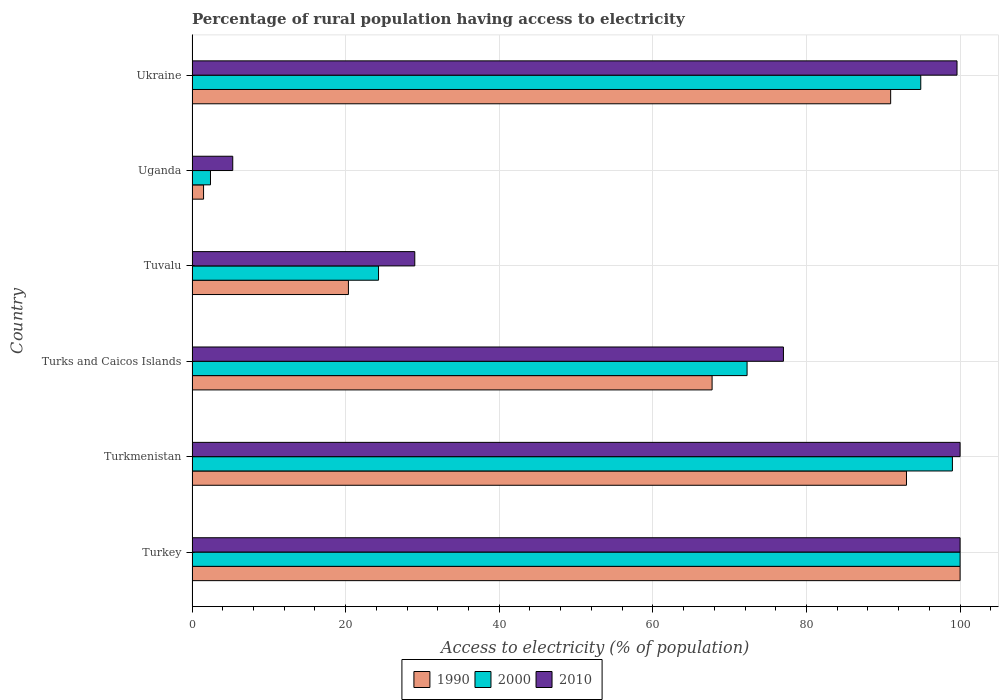How many groups of bars are there?
Ensure brevity in your answer.  6. Are the number of bars on each tick of the Y-axis equal?
Your answer should be very brief. Yes. How many bars are there on the 1st tick from the bottom?
Your answer should be very brief. 3. What is the label of the 4th group of bars from the top?
Offer a very short reply. Turks and Caicos Islands. What is the percentage of rural population having access to electricity in 1990 in Turkmenistan?
Give a very brief answer. 93.02. Across all countries, what is the maximum percentage of rural population having access to electricity in 2010?
Your response must be concise. 100. In which country was the percentage of rural population having access to electricity in 1990 minimum?
Offer a very short reply. Uganda. What is the total percentage of rural population having access to electricity in 2000 in the graph?
Provide a succinct answer. 392.83. What is the difference between the percentage of rural population having access to electricity in 2010 in Uganda and that in Ukraine?
Make the answer very short. -94.3. What is the difference between the percentage of rural population having access to electricity in 2000 in Uganda and the percentage of rural population having access to electricity in 1990 in Tuvalu?
Provide a short and direct response. -17.96. What is the average percentage of rural population having access to electricity in 2010 per country?
Your answer should be very brief. 68.48. What is the difference between the percentage of rural population having access to electricity in 2010 and percentage of rural population having access to electricity in 1990 in Turkmenistan?
Ensure brevity in your answer.  6.98. In how many countries, is the percentage of rural population having access to electricity in 2000 greater than 84 %?
Provide a short and direct response. 3. What is the ratio of the percentage of rural population having access to electricity in 1990 in Uganda to that in Ukraine?
Ensure brevity in your answer.  0.02. What is the difference between the highest and the second highest percentage of rural population having access to electricity in 2010?
Provide a short and direct response. 0. What is the difference between the highest and the lowest percentage of rural population having access to electricity in 2000?
Your response must be concise. 97.6. What does the 2nd bar from the top in Turks and Caicos Islands represents?
Provide a succinct answer. 2000. How many bars are there?
Give a very brief answer. 18. How many countries are there in the graph?
Your answer should be compact. 6. What is the difference between two consecutive major ticks on the X-axis?
Provide a succinct answer. 20. Are the values on the major ticks of X-axis written in scientific E-notation?
Offer a terse response. No. Where does the legend appear in the graph?
Ensure brevity in your answer.  Bottom center. How many legend labels are there?
Your response must be concise. 3. What is the title of the graph?
Keep it short and to the point. Percentage of rural population having access to electricity. What is the label or title of the X-axis?
Your response must be concise. Access to electricity (% of population). What is the label or title of the Y-axis?
Your answer should be very brief. Country. What is the Access to electricity (% of population) of 1990 in Turkey?
Give a very brief answer. 100. What is the Access to electricity (% of population) of 1990 in Turkmenistan?
Your answer should be compact. 93.02. What is the Access to electricity (% of population) of 2000 in Turkmenistan?
Keep it short and to the point. 99. What is the Access to electricity (% of population) of 1990 in Turks and Caicos Islands?
Your response must be concise. 67.71. What is the Access to electricity (% of population) of 2000 in Turks and Caicos Islands?
Provide a short and direct response. 72.27. What is the Access to electricity (% of population) in 2010 in Turks and Caicos Islands?
Your answer should be very brief. 77. What is the Access to electricity (% of population) of 1990 in Tuvalu?
Provide a short and direct response. 20.36. What is the Access to electricity (% of population) of 2000 in Tuvalu?
Offer a very short reply. 24.28. What is the Access to electricity (% of population) of 2000 in Uganda?
Give a very brief answer. 2.4. What is the Access to electricity (% of population) in 1990 in Ukraine?
Give a very brief answer. 90.96. What is the Access to electricity (% of population) in 2000 in Ukraine?
Provide a short and direct response. 94.88. What is the Access to electricity (% of population) in 2010 in Ukraine?
Provide a succinct answer. 99.6. Across all countries, what is the maximum Access to electricity (% of population) in 1990?
Offer a terse response. 100. Across all countries, what is the minimum Access to electricity (% of population) of 1990?
Provide a short and direct response. 1.5. Across all countries, what is the minimum Access to electricity (% of population) of 2010?
Provide a short and direct response. 5.3. What is the total Access to electricity (% of population) of 1990 in the graph?
Provide a short and direct response. 373.55. What is the total Access to electricity (% of population) in 2000 in the graph?
Offer a very short reply. 392.83. What is the total Access to electricity (% of population) in 2010 in the graph?
Give a very brief answer. 410.9. What is the difference between the Access to electricity (% of population) of 1990 in Turkey and that in Turkmenistan?
Your answer should be very brief. 6.98. What is the difference between the Access to electricity (% of population) of 2000 in Turkey and that in Turkmenistan?
Your response must be concise. 1. What is the difference between the Access to electricity (% of population) in 2010 in Turkey and that in Turkmenistan?
Provide a succinct answer. 0. What is the difference between the Access to electricity (% of population) of 1990 in Turkey and that in Turks and Caicos Islands?
Keep it short and to the point. 32.29. What is the difference between the Access to electricity (% of population) of 2000 in Turkey and that in Turks and Caicos Islands?
Keep it short and to the point. 27.73. What is the difference between the Access to electricity (% of population) of 1990 in Turkey and that in Tuvalu?
Offer a very short reply. 79.64. What is the difference between the Access to electricity (% of population) in 2000 in Turkey and that in Tuvalu?
Your answer should be very brief. 75.72. What is the difference between the Access to electricity (% of population) of 1990 in Turkey and that in Uganda?
Provide a short and direct response. 98.5. What is the difference between the Access to electricity (% of population) of 2000 in Turkey and that in Uganda?
Your answer should be very brief. 97.6. What is the difference between the Access to electricity (% of population) of 2010 in Turkey and that in Uganda?
Provide a succinct answer. 94.7. What is the difference between the Access to electricity (% of population) of 1990 in Turkey and that in Ukraine?
Ensure brevity in your answer.  9.04. What is the difference between the Access to electricity (% of population) in 2000 in Turkey and that in Ukraine?
Make the answer very short. 5.12. What is the difference between the Access to electricity (% of population) in 2010 in Turkey and that in Ukraine?
Ensure brevity in your answer.  0.4. What is the difference between the Access to electricity (% of population) of 1990 in Turkmenistan and that in Turks and Caicos Islands?
Provide a short and direct response. 25.31. What is the difference between the Access to electricity (% of population) in 2000 in Turkmenistan and that in Turks and Caicos Islands?
Provide a short and direct response. 26.73. What is the difference between the Access to electricity (% of population) in 2010 in Turkmenistan and that in Turks and Caicos Islands?
Your response must be concise. 23. What is the difference between the Access to electricity (% of population) in 1990 in Turkmenistan and that in Tuvalu?
Give a very brief answer. 72.66. What is the difference between the Access to electricity (% of population) in 2000 in Turkmenistan and that in Tuvalu?
Your answer should be very brief. 74.72. What is the difference between the Access to electricity (% of population) in 1990 in Turkmenistan and that in Uganda?
Give a very brief answer. 91.52. What is the difference between the Access to electricity (% of population) of 2000 in Turkmenistan and that in Uganda?
Offer a very short reply. 96.6. What is the difference between the Access to electricity (% of population) of 2010 in Turkmenistan and that in Uganda?
Provide a succinct answer. 94.7. What is the difference between the Access to electricity (% of population) of 1990 in Turkmenistan and that in Ukraine?
Keep it short and to the point. 2.06. What is the difference between the Access to electricity (% of population) of 2000 in Turkmenistan and that in Ukraine?
Your answer should be compact. 4.12. What is the difference between the Access to electricity (% of population) in 2010 in Turkmenistan and that in Ukraine?
Keep it short and to the point. 0.4. What is the difference between the Access to electricity (% of population) in 1990 in Turks and Caicos Islands and that in Tuvalu?
Your answer should be compact. 47.35. What is the difference between the Access to electricity (% of population) of 2000 in Turks and Caicos Islands and that in Tuvalu?
Give a very brief answer. 47.98. What is the difference between the Access to electricity (% of population) in 1990 in Turks and Caicos Islands and that in Uganda?
Offer a very short reply. 66.21. What is the difference between the Access to electricity (% of population) of 2000 in Turks and Caicos Islands and that in Uganda?
Give a very brief answer. 69.86. What is the difference between the Access to electricity (% of population) in 2010 in Turks and Caicos Islands and that in Uganda?
Your response must be concise. 71.7. What is the difference between the Access to electricity (% of population) in 1990 in Turks and Caicos Islands and that in Ukraine?
Ensure brevity in your answer.  -23.25. What is the difference between the Access to electricity (% of population) of 2000 in Turks and Caicos Islands and that in Ukraine?
Provide a short and direct response. -22.62. What is the difference between the Access to electricity (% of population) in 2010 in Turks and Caicos Islands and that in Ukraine?
Give a very brief answer. -22.6. What is the difference between the Access to electricity (% of population) in 1990 in Tuvalu and that in Uganda?
Make the answer very short. 18.86. What is the difference between the Access to electricity (% of population) in 2000 in Tuvalu and that in Uganda?
Provide a succinct answer. 21.88. What is the difference between the Access to electricity (% of population) in 2010 in Tuvalu and that in Uganda?
Give a very brief answer. 23.7. What is the difference between the Access to electricity (% of population) of 1990 in Tuvalu and that in Ukraine?
Make the answer very short. -70.6. What is the difference between the Access to electricity (% of population) in 2000 in Tuvalu and that in Ukraine?
Provide a short and direct response. -70.6. What is the difference between the Access to electricity (% of population) of 2010 in Tuvalu and that in Ukraine?
Offer a terse response. -70.6. What is the difference between the Access to electricity (% of population) in 1990 in Uganda and that in Ukraine?
Ensure brevity in your answer.  -89.46. What is the difference between the Access to electricity (% of population) in 2000 in Uganda and that in Ukraine?
Make the answer very short. -92.48. What is the difference between the Access to electricity (% of population) in 2010 in Uganda and that in Ukraine?
Your answer should be very brief. -94.3. What is the difference between the Access to electricity (% of population) in 2000 in Turkey and the Access to electricity (% of population) in 2010 in Turkmenistan?
Give a very brief answer. 0. What is the difference between the Access to electricity (% of population) of 1990 in Turkey and the Access to electricity (% of population) of 2000 in Turks and Caicos Islands?
Make the answer very short. 27.73. What is the difference between the Access to electricity (% of population) of 1990 in Turkey and the Access to electricity (% of population) of 2000 in Tuvalu?
Provide a short and direct response. 75.72. What is the difference between the Access to electricity (% of population) of 1990 in Turkey and the Access to electricity (% of population) of 2010 in Tuvalu?
Make the answer very short. 71. What is the difference between the Access to electricity (% of population) in 1990 in Turkey and the Access to electricity (% of population) in 2000 in Uganda?
Ensure brevity in your answer.  97.6. What is the difference between the Access to electricity (% of population) of 1990 in Turkey and the Access to electricity (% of population) of 2010 in Uganda?
Offer a terse response. 94.7. What is the difference between the Access to electricity (% of population) in 2000 in Turkey and the Access to electricity (% of population) in 2010 in Uganda?
Provide a short and direct response. 94.7. What is the difference between the Access to electricity (% of population) in 1990 in Turkey and the Access to electricity (% of population) in 2000 in Ukraine?
Keep it short and to the point. 5.12. What is the difference between the Access to electricity (% of population) of 1990 in Turkey and the Access to electricity (% of population) of 2010 in Ukraine?
Make the answer very short. 0.4. What is the difference between the Access to electricity (% of population) in 2000 in Turkey and the Access to electricity (% of population) in 2010 in Ukraine?
Your answer should be compact. 0.4. What is the difference between the Access to electricity (% of population) in 1990 in Turkmenistan and the Access to electricity (% of population) in 2000 in Turks and Caicos Islands?
Make the answer very short. 20.75. What is the difference between the Access to electricity (% of population) of 1990 in Turkmenistan and the Access to electricity (% of population) of 2010 in Turks and Caicos Islands?
Offer a terse response. 16.02. What is the difference between the Access to electricity (% of population) of 2000 in Turkmenistan and the Access to electricity (% of population) of 2010 in Turks and Caicos Islands?
Provide a short and direct response. 22. What is the difference between the Access to electricity (% of population) of 1990 in Turkmenistan and the Access to electricity (% of population) of 2000 in Tuvalu?
Offer a very short reply. 68.74. What is the difference between the Access to electricity (% of population) of 1990 in Turkmenistan and the Access to electricity (% of population) of 2010 in Tuvalu?
Offer a terse response. 64.02. What is the difference between the Access to electricity (% of population) of 1990 in Turkmenistan and the Access to electricity (% of population) of 2000 in Uganda?
Provide a succinct answer. 90.62. What is the difference between the Access to electricity (% of population) of 1990 in Turkmenistan and the Access to electricity (% of population) of 2010 in Uganda?
Your answer should be compact. 87.72. What is the difference between the Access to electricity (% of population) of 2000 in Turkmenistan and the Access to electricity (% of population) of 2010 in Uganda?
Provide a short and direct response. 93.7. What is the difference between the Access to electricity (% of population) in 1990 in Turkmenistan and the Access to electricity (% of population) in 2000 in Ukraine?
Ensure brevity in your answer.  -1.86. What is the difference between the Access to electricity (% of population) in 1990 in Turkmenistan and the Access to electricity (% of population) in 2010 in Ukraine?
Offer a terse response. -6.58. What is the difference between the Access to electricity (% of population) in 2000 in Turkmenistan and the Access to electricity (% of population) in 2010 in Ukraine?
Give a very brief answer. -0.6. What is the difference between the Access to electricity (% of population) of 1990 in Turks and Caicos Islands and the Access to electricity (% of population) of 2000 in Tuvalu?
Keep it short and to the point. 43.43. What is the difference between the Access to electricity (% of population) of 1990 in Turks and Caicos Islands and the Access to electricity (% of population) of 2010 in Tuvalu?
Give a very brief answer. 38.71. What is the difference between the Access to electricity (% of population) in 2000 in Turks and Caicos Islands and the Access to electricity (% of population) in 2010 in Tuvalu?
Offer a very short reply. 43.27. What is the difference between the Access to electricity (% of population) in 1990 in Turks and Caicos Islands and the Access to electricity (% of population) in 2000 in Uganda?
Make the answer very short. 65.31. What is the difference between the Access to electricity (% of population) of 1990 in Turks and Caicos Islands and the Access to electricity (% of population) of 2010 in Uganda?
Your answer should be very brief. 62.41. What is the difference between the Access to electricity (% of population) in 2000 in Turks and Caicos Islands and the Access to electricity (% of population) in 2010 in Uganda?
Ensure brevity in your answer.  66.97. What is the difference between the Access to electricity (% of population) of 1990 in Turks and Caicos Islands and the Access to electricity (% of population) of 2000 in Ukraine?
Your answer should be very brief. -27.17. What is the difference between the Access to electricity (% of population) of 1990 in Turks and Caicos Islands and the Access to electricity (% of population) of 2010 in Ukraine?
Your answer should be very brief. -31.89. What is the difference between the Access to electricity (% of population) of 2000 in Turks and Caicos Islands and the Access to electricity (% of population) of 2010 in Ukraine?
Your answer should be compact. -27.34. What is the difference between the Access to electricity (% of population) of 1990 in Tuvalu and the Access to electricity (% of population) of 2000 in Uganda?
Ensure brevity in your answer.  17.96. What is the difference between the Access to electricity (% of population) of 1990 in Tuvalu and the Access to electricity (% of population) of 2010 in Uganda?
Provide a short and direct response. 15.06. What is the difference between the Access to electricity (% of population) of 2000 in Tuvalu and the Access to electricity (% of population) of 2010 in Uganda?
Your answer should be very brief. 18.98. What is the difference between the Access to electricity (% of population) in 1990 in Tuvalu and the Access to electricity (% of population) in 2000 in Ukraine?
Provide a succinct answer. -74.52. What is the difference between the Access to electricity (% of population) in 1990 in Tuvalu and the Access to electricity (% of population) in 2010 in Ukraine?
Your answer should be very brief. -79.24. What is the difference between the Access to electricity (% of population) in 2000 in Tuvalu and the Access to electricity (% of population) in 2010 in Ukraine?
Your answer should be compact. -75.32. What is the difference between the Access to electricity (% of population) in 1990 in Uganda and the Access to electricity (% of population) in 2000 in Ukraine?
Give a very brief answer. -93.38. What is the difference between the Access to electricity (% of population) of 1990 in Uganda and the Access to electricity (% of population) of 2010 in Ukraine?
Provide a succinct answer. -98.1. What is the difference between the Access to electricity (% of population) in 2000 in Uganda and the Access to electricity (% of population) in 2010 in Ukraine?
Keep it short and to the point. -97.2. What is the average Access to electricity (% of population) in 1990 per country?
Offer a very short reply. 62.26. What is the average Access to electricity (% of population) of 2000 per country?
Your answer should be very brief. 65.47. What is the average Access to electricity (% of population) of 2010 per country?
Offer a terse response. 68.48. What is the difference between the Access to electricity (% of population) of 1990 and Access to electricity (% of population) of 2000 in Turkey?
Provide a succinct answer. 0. What is the difference between the Access to electricity (% of population) in 1990 and Access to electricity (% of population) in 2010 in Turkey?
Your answer should be compact. 0. What is the difference between the Access to electricity (% of population) in 2000 and Access to electricity (% of population) in 2010 in Turkey?
Offer a terse response. 0. What is the difference between the Access to electricity (% of population) of 1990 and Access to electricity (% of population) of 2000 in Turkmenistan?
Provide a short and direct response. -5.98. What is the difference between the Access to electricity (% of population) in 1990 and Access to electricity (% of population) in 2010 in Turkmenistan?
Provide a short and direct response. -6.98. What is the difference between the Access to electricity (% of population) of 2000 and Access to electricity (% of population) of 2010 in Turkmenistan?
Your answer should be very brief. -1. What is the difference between the Access to electricity (% of population) in 1990 and Access to electricity (% of population) in 2000 in Turks and Caicos Islands?
Ensure brevity in your answer.  -4.55. What is the difference between the Access to electricity (% of population) in 1990 and Access to electricity (% of population) in 2010 in Turks and Caicos Islands?
Give a very brief answer. -9.29. What is the difference between the Access to electricity (% of population) in 2000 and Access to electricity (% of population) in 2010 in Turks and Caicos Islands?
Offer a terse response. -4.74. What is the difference between the Access to electricity (% of population) in 1990 and Access to electricity (% of population) in 2000 in Tuvalu?
Your answer should be very brief. -3.92. What is the difference between the Access to electricity (% of population) in 1990 and Access to electricity (% of population) in 2010 in Tuvalu?
Keep it short and to the point. -8.64. What is the difference between the Access to electricity (% of population) of 2000 and Access to electricity (% of population) of 2010 in Tuvalu?
Make the answer very short. -4.72. What is the difference between the Access to electricity (% of population) in 1990 and Access to electricity (% of population) in 2000 in Uganda?
Make the answer very short. -0.9. What is the difference between the Access to electricity (% of population) in 1990 and Access to electricity (% of population) in 2010 in Uganda?
Keep it short and to the point. -3.8. What is the difference between the Access to electricity (% of population) of 1990 and Access to electricity (% of population) of 2000 in Ukraine?
Provide a short and direct response. -3.92. What is the difference between the Access to electricity (% of population) in 1990 and Access to electricity (% of population) in 2010 in Ukraine?
Provide a succinct answer. -8.64. What is the difference between the Access to electricity (% of population) in 2000 and Access to electricity (% of population) in 2010 in Ukraine?
Keep it short and to the point. -4.72. What is the ratio of the Access to electricity (% of population) in 1990 in Turkey to that in Turkmenistan?
Your answer should be compact. 1.07. What is the ratio of the Access to electricity (% of population) of 2010 in Turkey to that in Turkmenistan?
Offer a very short reply. 1. What is the ratio of the Access to electricity (% of population) in 1990 in Turkey to that in Turks and Caicos Islands?
Provide a short and direct response. 1.48. What is the ratio of the Access to electricity (% of population) in 2000 in Turkey to that in Turks and Caicos Islands?
Keep it short and to the point. 1.38. What is the ratio of the Access to electricity (% of population) of 2010 in Turkey to that in Turks and Caicos Islands?
Your response must be concise. 1.3. What is the ratio of the Access to electricity (% of population) of 1990 in Turkey to that in Tuvalu?
Offer a very short reply. 4.91. What is the ratio of the Access to electricity (% of population) of 2000 in Turkey to that in Tuvalu?
Keep it short and to the point. 4.12. What is the ratio of the Access to electricity (% of population) in 2010 in Turkey to that in Tuvalu?
Offer a terse response. 3.45. What is the ratio of the Access to electricity (% of population) of 1990 in Turkey to that in Uganda?
Your response must be concise. 66.67. What is the ratio of the Access to electricity (% of population) in 2000 in Turkey to that in Uganda?
Provide a succinct answer. 41.67. What is the ratio of the Access to electricity (% of population) of 2010 in Turkey to that in Uganda?
Offer a very short reply. 18.87. What is the ratio of the Access to electricity (% of population) in 1990 in Turkey to that in Ukraine?
Provide a short and direct response. 1.1. What is the ratio of the Access to electricity (% of population) in 2000 in Turkey to that in Ukraine?
Offer a very short reply. 1.05. What is the ratio of the Access to electricity (% of population) in 1990 in Turkmenistan to that in Turks and Caicos Islands?
Give a very brief answer. 1.37. What is the ratio of the Access to electricity (% of population) in 2000 in Turkmenistan to that in Turks and Caicos Islands?
Provide a succinct answer. 1.37. What is the ratio of the Access to electricity (% of population) in 2010 in Turkmenistan to that in Turks and Caicos Islands?
Your answer should be compact. 1.3. What is the ratio of the Access to electricity (% of population) in 1990 in Turkmenistan to that in Tuvalu?
Keep it short and to the point. 4.57. What is the ratio of the Access to electricity (% of population) of 2000 in Turkmenistan to that in Tuvalu?
Offer a very short reply. 4.08. What is the ratio of the Access to electricity (% of population) in 2010 in Turkmenistan to that in Tuvalu?
Your response must be concise. 3.45. What is the ratio of the Access to electricity (% of population) of 1990 in Turkmenistan to that in Uganda?
Your answer should be compact. 62.01. What is the ratio of the Access to electricity (% of population) of 2000 in Turkmenistan to that in Uganda?
Offer a very short reply. 41.25. What is the ratio of the Access to electricity (% of population) of 2010 in Turkmenistan to that in Uganda?
Your response must be concise. 18.87. What is the ratio of the Access to electricity (% of population) in 1990 in Turkmenistan to that in Ukraine?
Keep it short and to the point. 1.02. What is the ratio of the Access to electricity (% of population) of 2000 in Turkmenistan to that in Ukraine?
Provide a succinct answer. 1.04. What is the ratio of the Access to electricity (% of population) of 1990 in Turks and Caicos Islands to that in Tuvalu?
Your answer should be very brief. 3.33. What is the ratio of the Access to electricity (% of population) in 2000 in Turks and Caicos Islands to that in Tuvalu?
Offer a very short reply. 2.98. What is the ratio of the Access to electricity (% of population) in 2010 in Turks and Caicos Islands to that in Tuvalu?
Your answer should be compact. 2.66. What is the ratio of the Access to electricity (% of population) in 1990 in Turks and Caicos Islands to that in Uganda?
Provide a succinct answer. 45.14. What is the ratio of the Access to electricity (% of population) in 2000 in Turks and Caicos Islands to that in Uganda?
Offer a terse response. 30.11. What is the ratio of the Access to electricity (% of population) of 2010 in Turks and Caicos Islands to that in Uganda?
Make the answer very short. 14.53. What is the ratio of the Access to electricity (% of population) in 1990 in Turks and Caicos Islands to that in Ukraine?
Your answer should be very brief. 0.74. What is the ratio of the Access to electricity (% of population) in 2000 in Turks and Caicos Islands to that in Ukraine?
Provide a succinct answer. 0.76. What is the ratio of the Access to electricity (% of population) in 2010 in Turks and Caicos Islands to that in Ukraine?
Give a very brief answer. 0.77. What is the ratio of the Access to electricity (% of population) in 1990 in Tuvalu to that in Uganda?
Offer a terse response. 13.57. What is the ratio of the Access to electricity (% of population) of 2000 in Tuvalu to that in Uganda?
Provide a short and direct response. 10.12. What is the ratio of the Access to electricity (% of population) of 2010 in Tuvalu to that in Uganda?
Offer a terse response. 5.47. What is the ratio of the Access to electricity (% of population) of 1990 in Tuvalu to that in Ukraine?
Provide a succinct answer. 0.22. What is the ratio of the Access to electricity (% of population) of 2000 in Tuvalu to that in Ukraine?
Offer a very short reply. 0.26. What is the ratio of the Access to electricity (% of population) of 2010 in Tuvalu to that in Ukraine?
Offer a terse response. 0.29. What is the ratio of the Access to electricity (% of population) in 1990 in Uganda to that in Ukraine?
Offer a terse response. 0.02. What is the ratio of the Access to electricity (% of population) in 2000 in Uganda to that in Ukraine?
Provide a succinct answer. 0.03. What is the ratio of the Access to electricity (% of population) in 2010 in Uganda to that in Ukraine?
Your response must be concise. 0.05. What is the difference between the highest and the second highest Access to electricity (% of population) of 1990?
Provide a short and direct response. 6.98. What is the difference between the highest and the second highest Access to electricity (% of population) of 2000?
Keep it short and to the point. 1. What is the difference between the highest and the lowest Access to electricity (% of population) in 1990?
Make the answer very short. 98.5. What is the difference between the highest and the lowest Access to electricity (% of population) in 2000?
Offer a terse response. 97.6. What is the difference between the highest and the lowest Access to electricity (% of population) of 2010?
Make the answer very short. 94.7. 